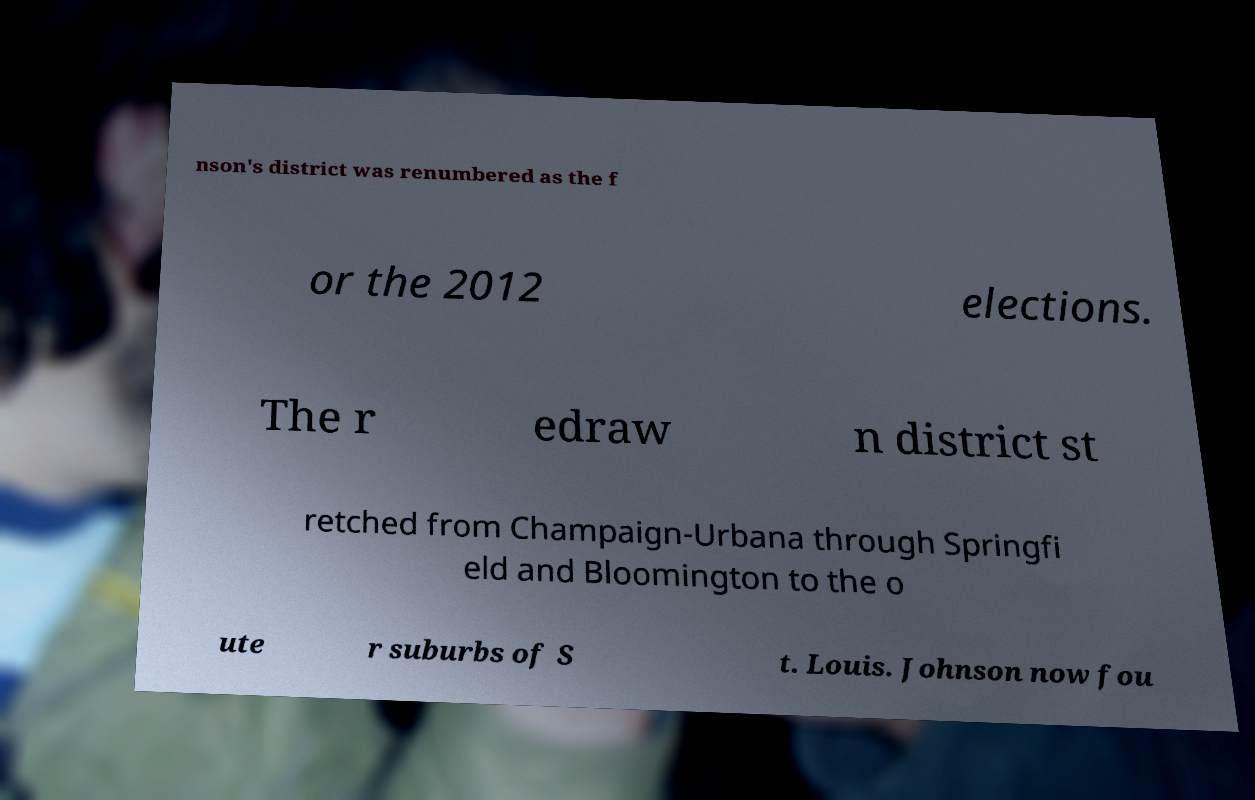Could you assist in decoding the text presented in this image and type it out clearly? nson's district was renumbered as the f or the 2012 elections. The r edraw n district st retched from Champaign-Urbana through Springfi eld and Bloomington to the o ute r suburbs of S t. Louis. Johnson now fou 